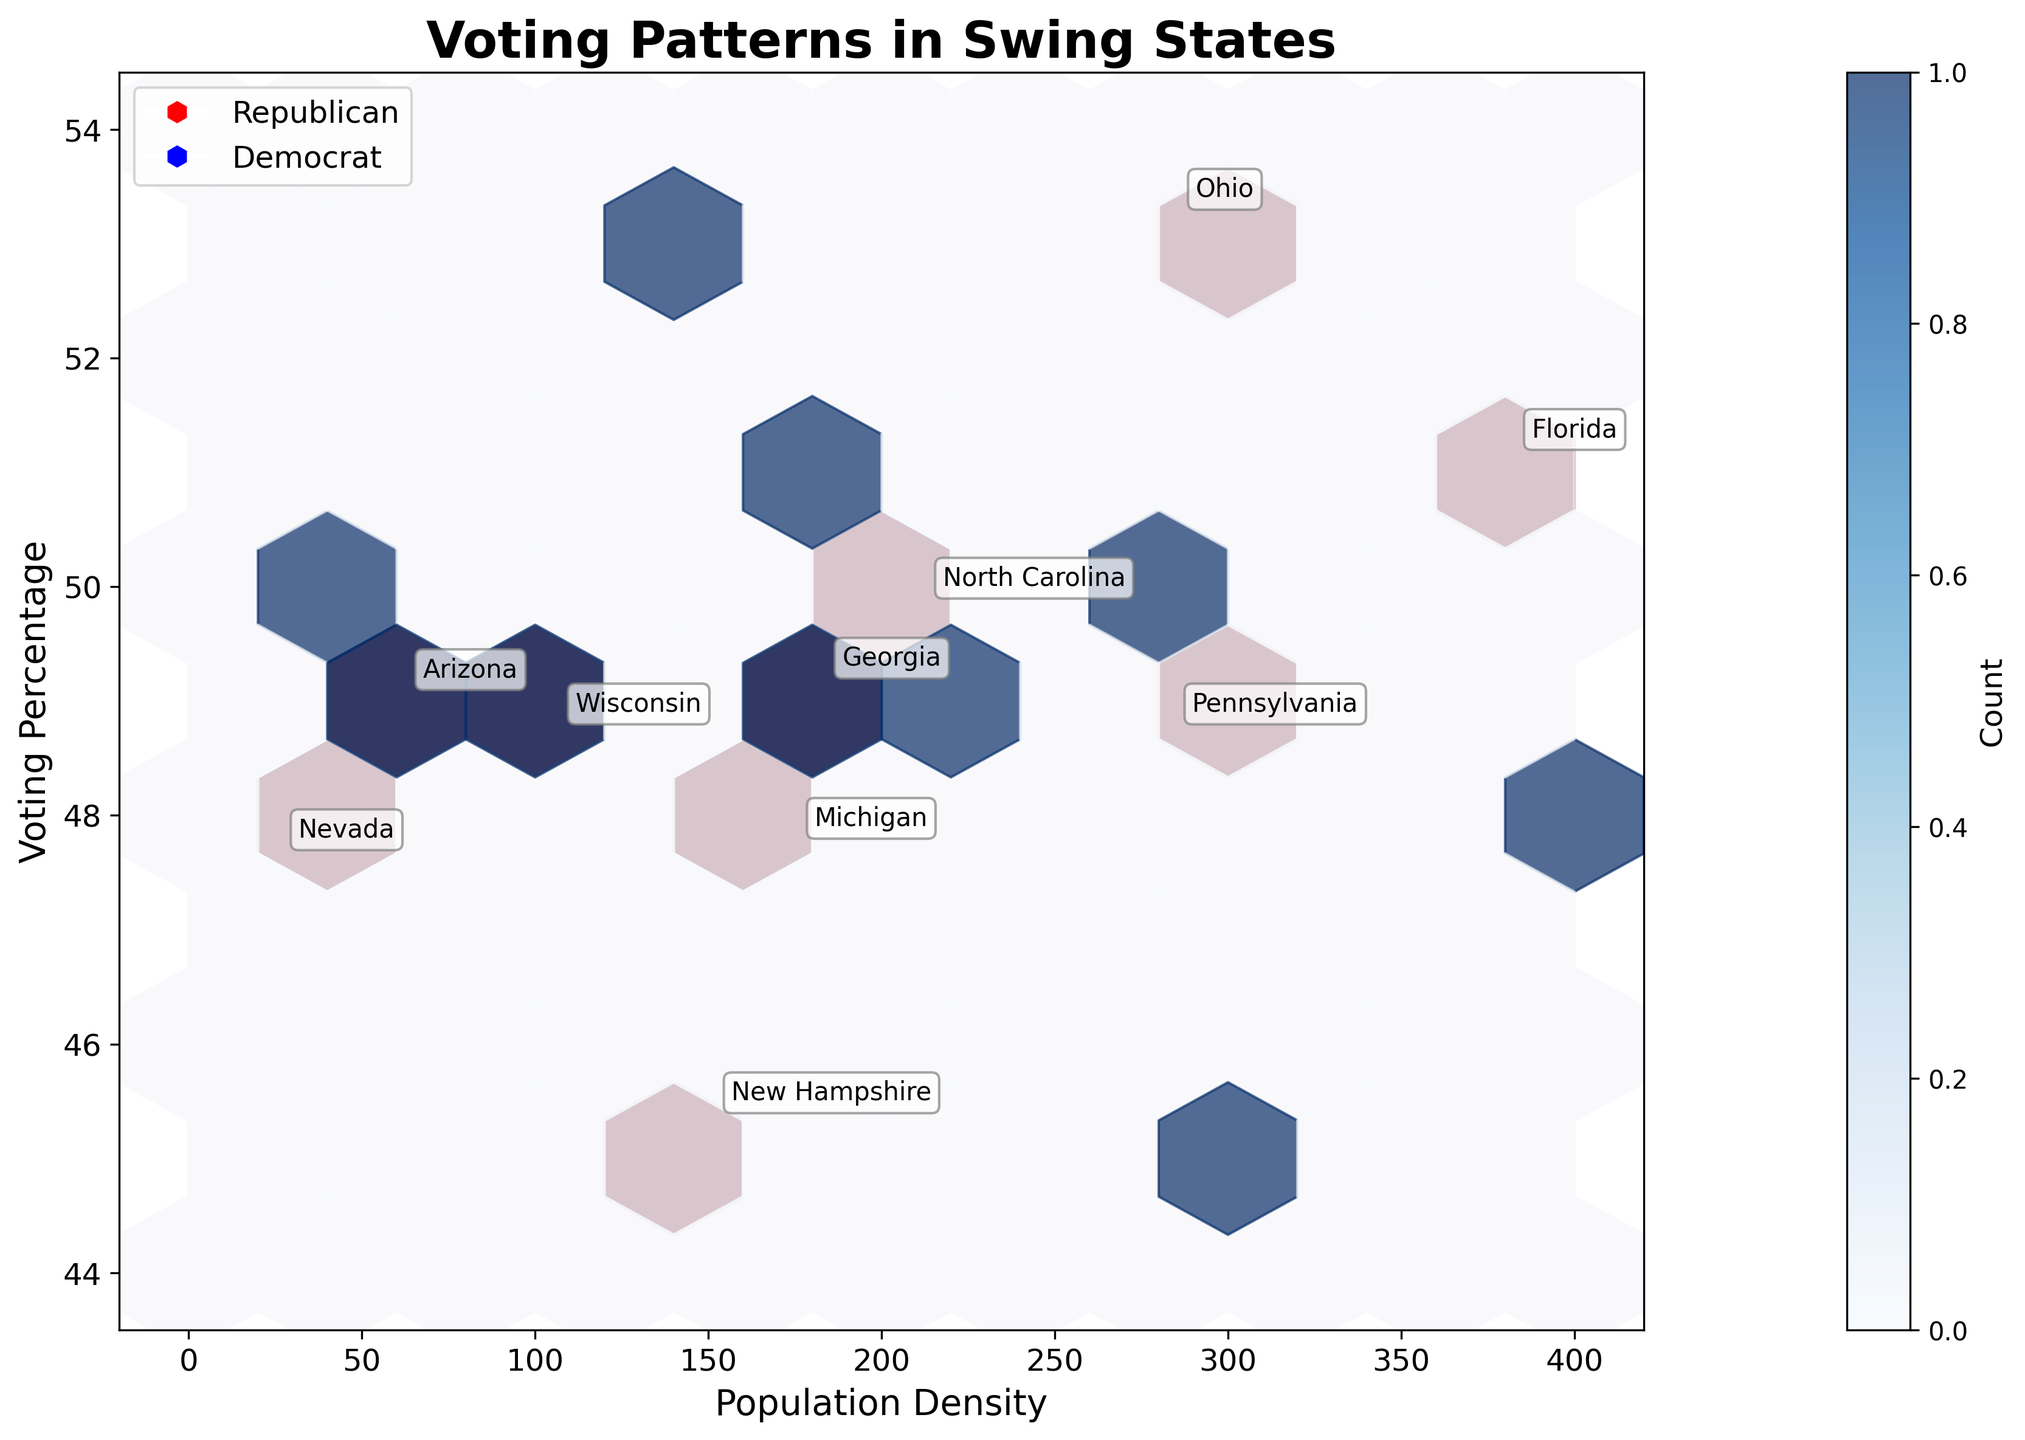What is the title of the hexbin plot? The title of the plot is displayed at the top and reads "Voting Patterns in Swing States".
Answer: Voting Patterns in Swing States What are the x-axis and y-axis labels in the plot? The x-axis label is "Population Density" and the y-axis label is "Voting Percentage", which are located alongside the respective axes.
Answer: Population Density, Voting Percentage Which color represents the Republican party in the plot? The hexagons for the Republican party are displayed in shades of red, indicated in the plot's legend.
Answer: Red Which state has the highest voting percentage among Democrats? By examining the figure, New Hampshire shows the highest voting percentage among Democrats with approximately 52.7%.
Answer: New Hampshire What is the relationship between population density and voting percentage for Democrats in Arizona? In Arizona, both Democrats and Republicans have similar voting percentages around 49.4%. The population density for Arizona is represented at 64.
Answer: Democrat voting percentage in Arizona is 49.4% with a population density of 64 What similarities do you observe in population density between Florida and Ohio? Both Florida and Ohio have similar population densities around 384 and 287 respectively.
Answer: Approximately similar densities Among the represented states, which party has a higher voting percentage in low-density areas? By examining the low-density areas on the hexbin plot, Democrats tend to have a higher voting percentage in areas like Nevada and New Hampshire.
Answer: Democrats How does the mean voting percentage of Democrats compare to Republicans across these states? To find the average, calculate the mean for each party from the data points. Democrats have consistently higher voting percentages in several states on the plot.
Answer: Democrats generally have a higher mean Which party received a higher voting percentage in Wisconsin? Both Democrats and Republicans in Wisconsin have close voting percentages, but Democrats have a slightly higher percentage with approximately 49.4%.
Answer: Democrats What general trend can be seen in the relationship between population density and voting percentage? The plot shows no clear trend where population density directly correlates with voting percentage as both parties have varied percentages across different densities.
Answer: No clear trend 